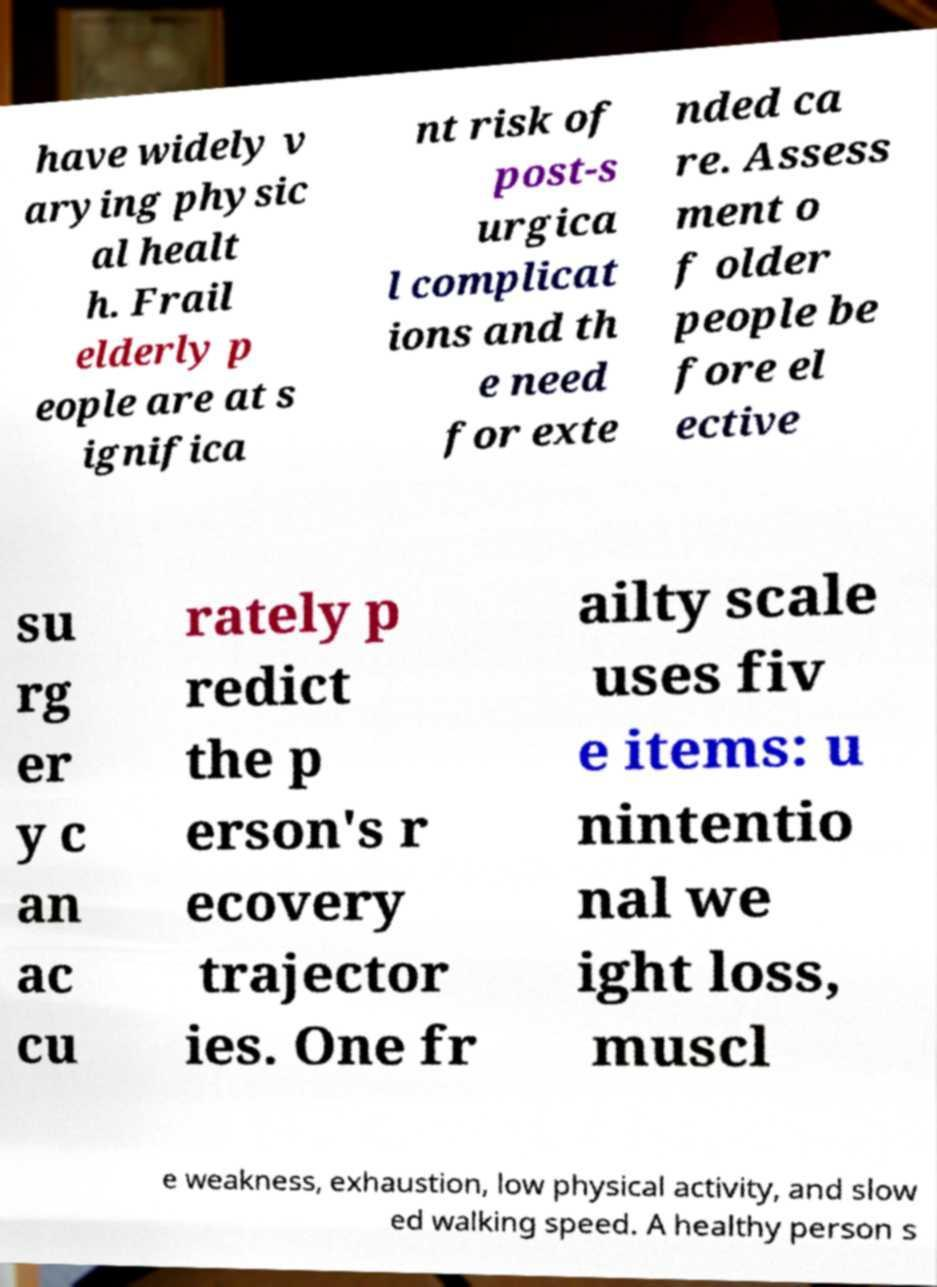For documentation purposes, I need the text within this image transcribed. Could you provide that? have widely v arying physic al healt h. Frail elderly p eople are at s ignifica nt risk of post-s urgica l complicat ions and th e need for exte nded ca re. Assess ment o f older people be fore el ective su rg er y c an ac cu rately p redict the p erson's r ecovery trajector ies. One fr ailty scale uses fiv e items: u nintentio nal we ight loss, muscl e weakness, exhaustion, low physical activity, and slow ed walking speed. A healthy person s 